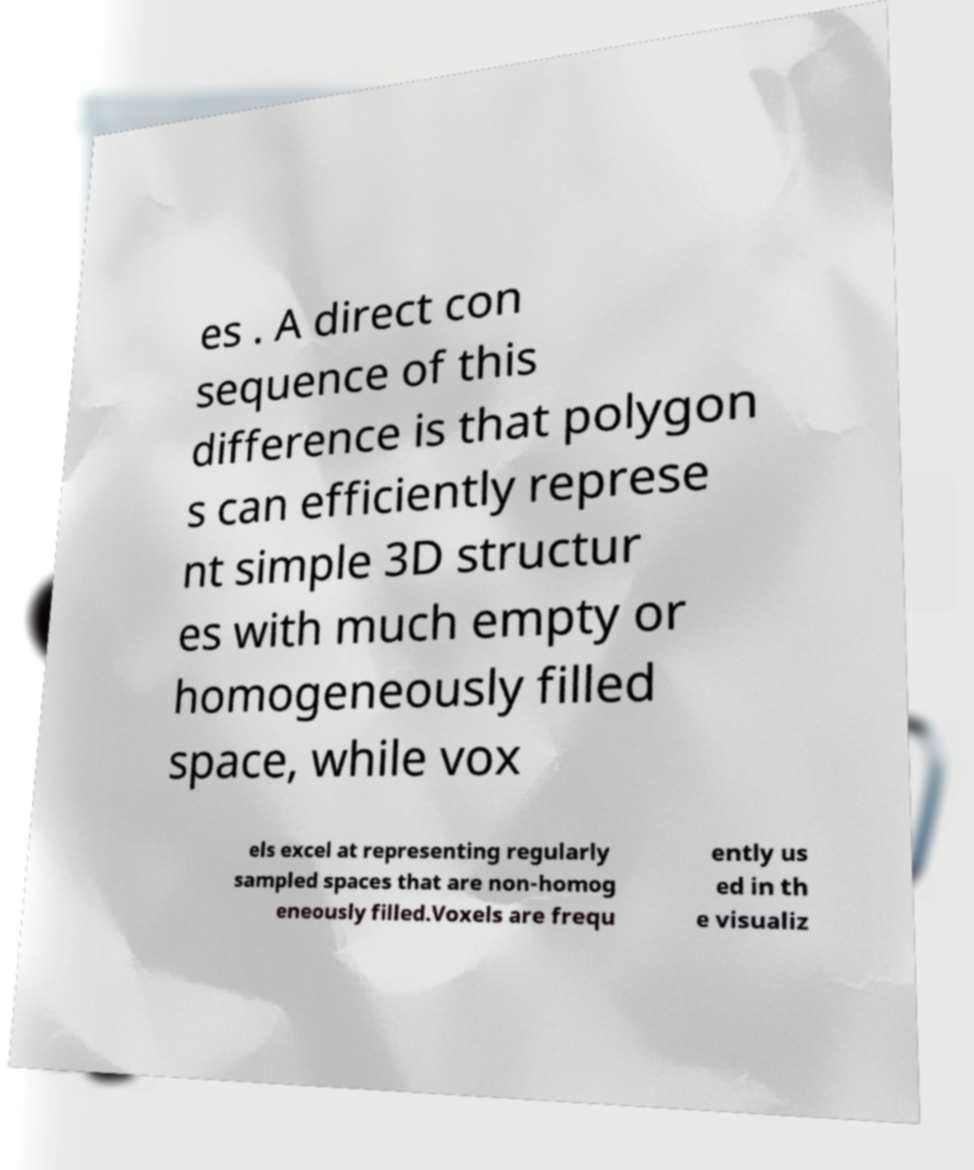For documentation purposes, I need the text within this image transcribed. Could you provide that? es . A direct con sequence of this difference is that polygon s can efficiently represe nt simple 3D structur es with much empty or homogeneously filled space, while vox els excel at representing regularly sampled spaces that are non-homog eneously filled.Voxels are frequ ently us ed in th e visualiz 